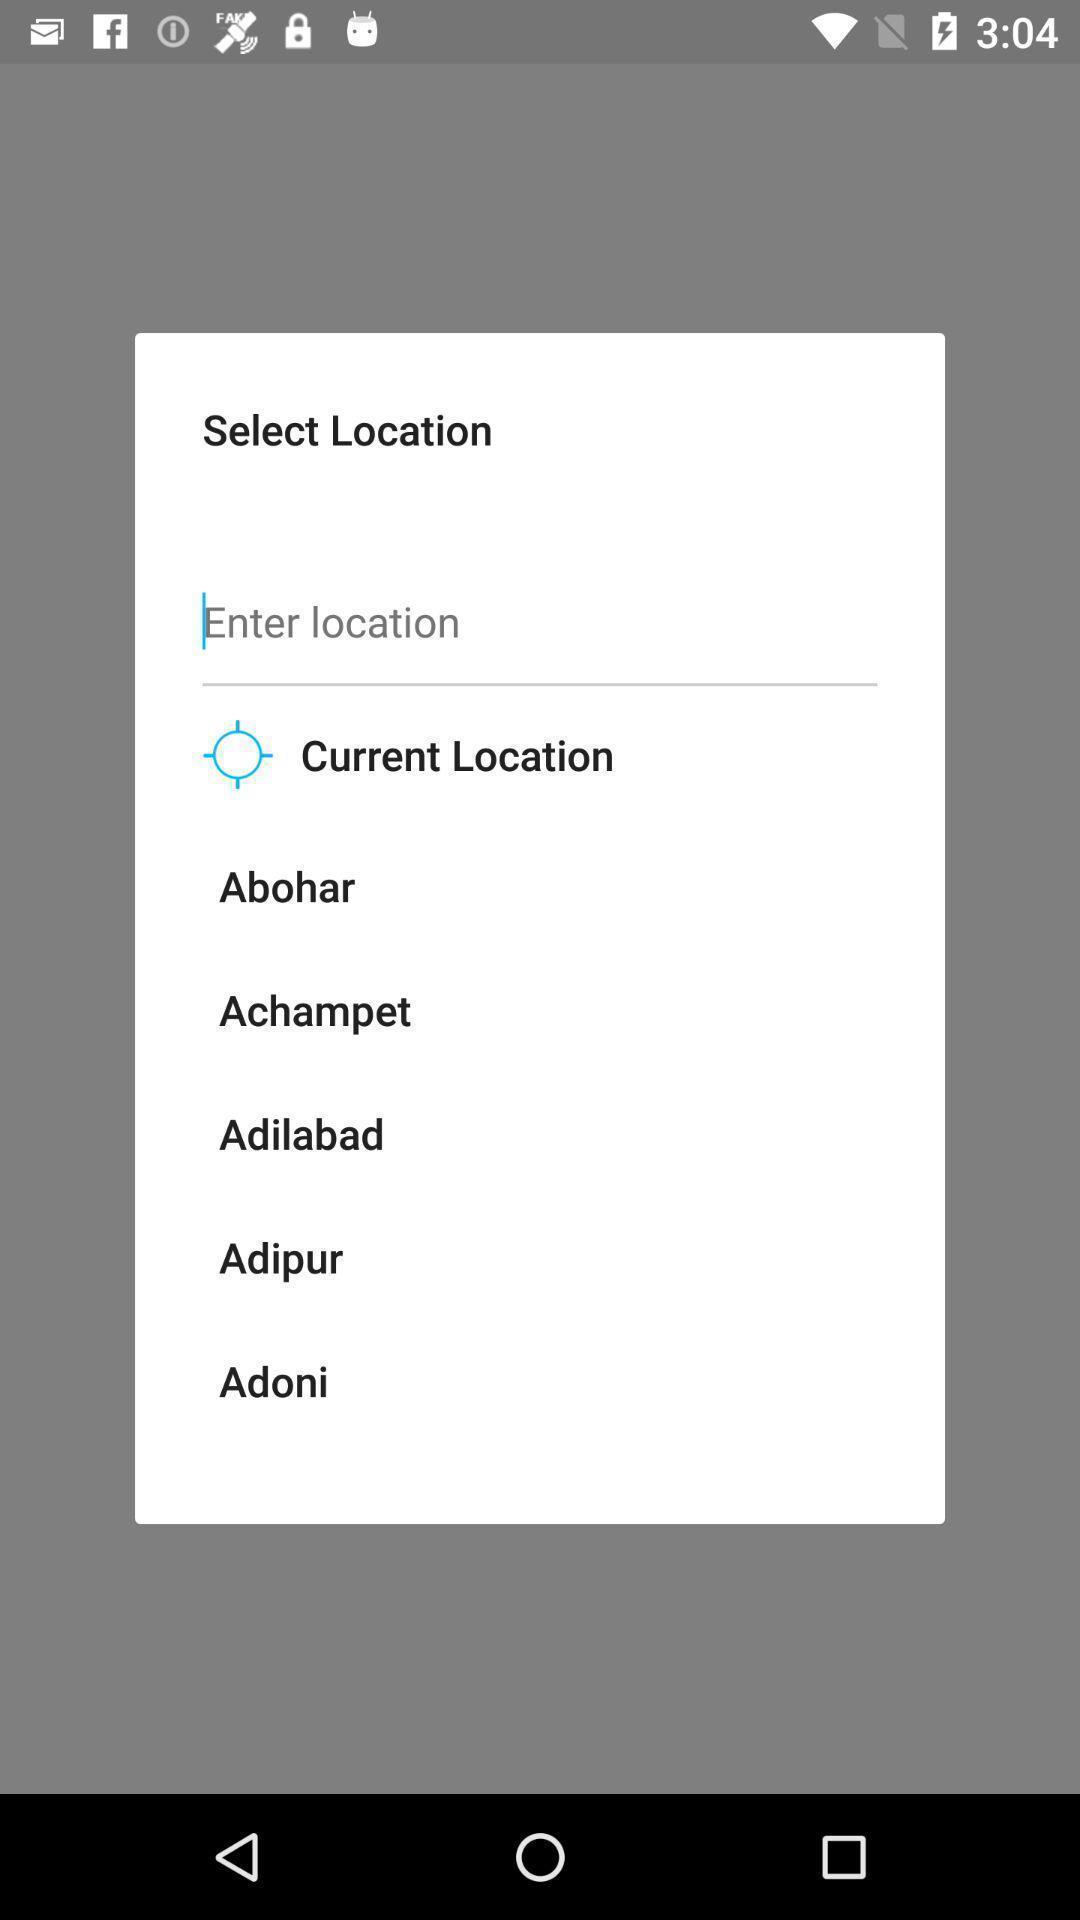What is the overall content of this screenshot? Pop-up shows search multiple locations on screen. 